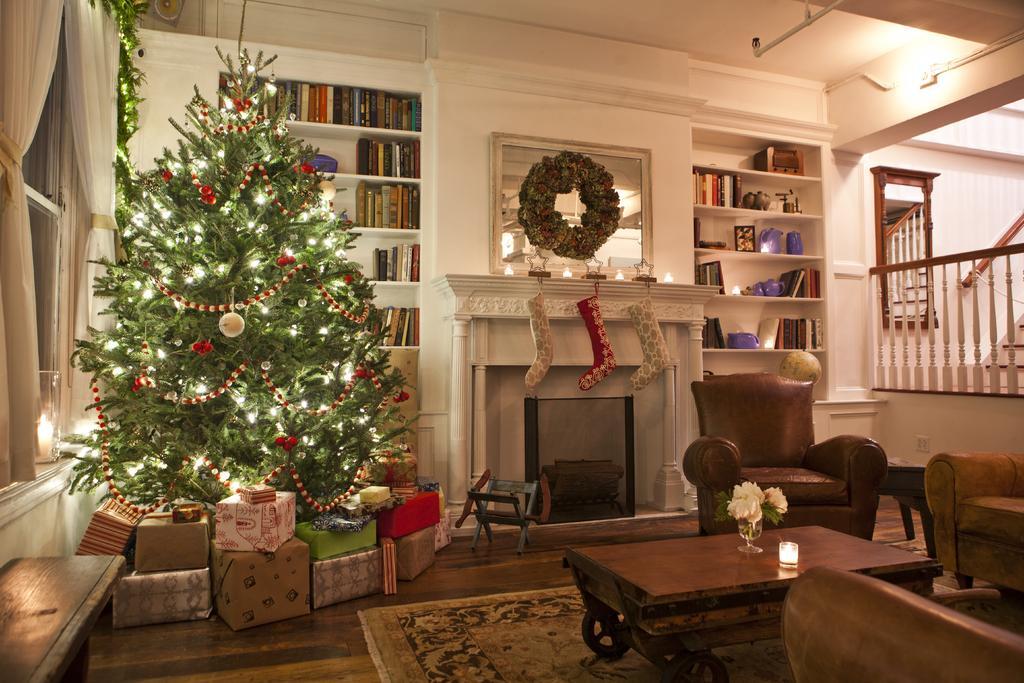Describe this image in one or two sentences. In this picture we can see a wall and shelves. We can see books in shelves. Here we can see christmas tree which is decorated very beautifully. This is a floor and a carpet. here these are chairs and a table and on the table we can see candle glass and a flower vase. These are stairs inside the house. 